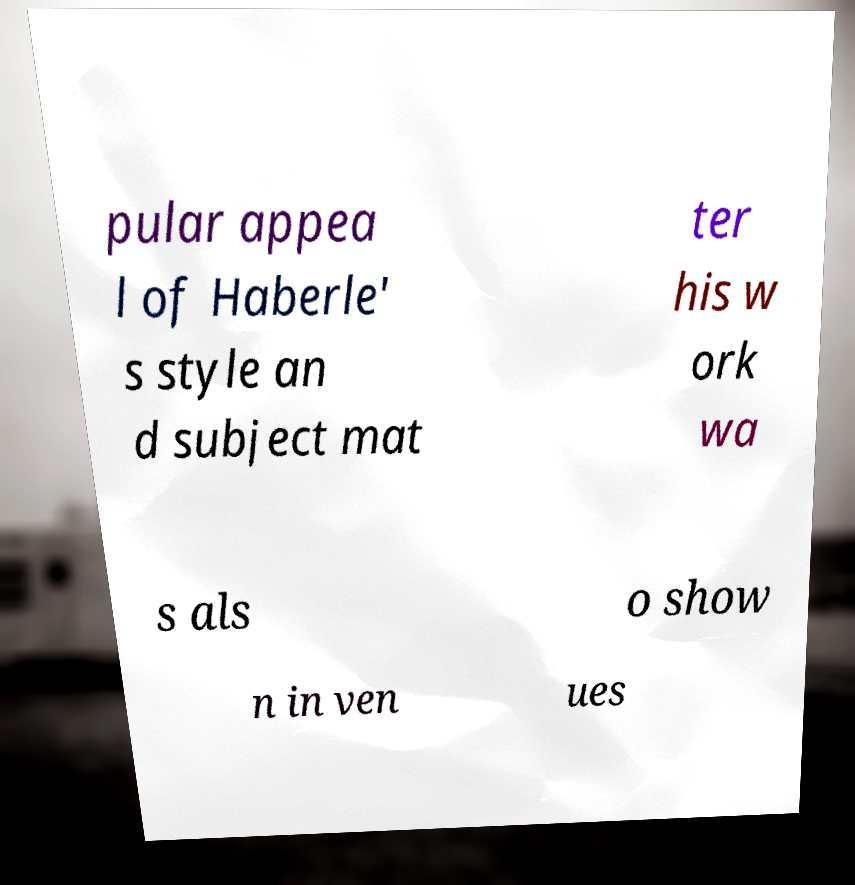For documentation purposes, I need the text within this image transcribed. Could you provide that? pular appea l of Haberle' s style an d subject mat ter his w ork wa s als o show n in ven ues 